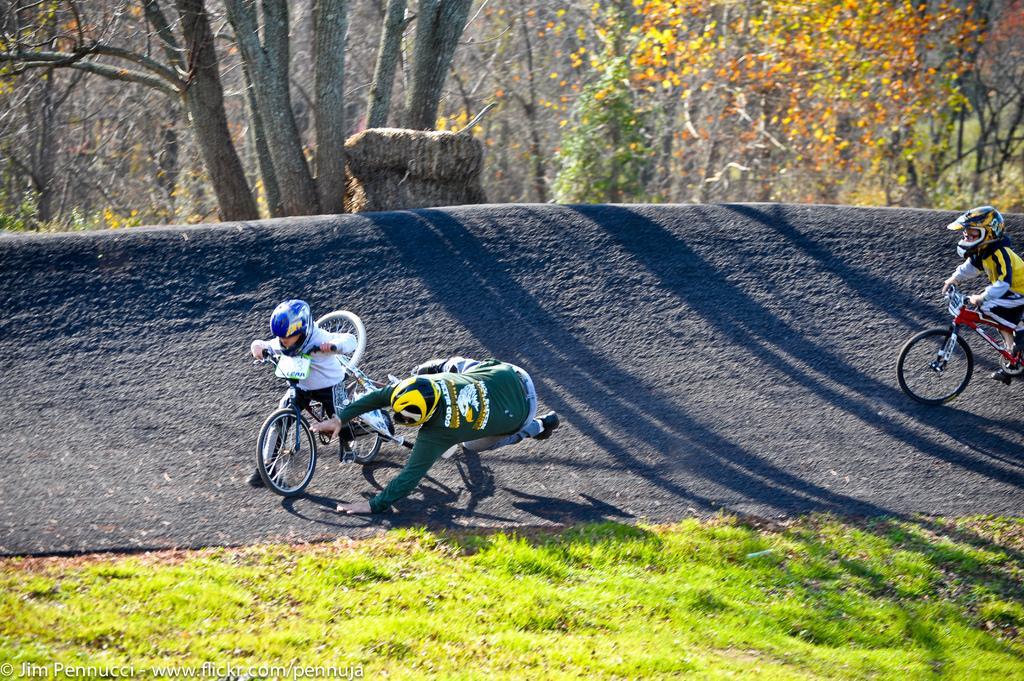In one or two sentences, can you explain what this image depicts? At the bottom of the image there is grass on the ground. Behind the grass there is a slope with few people are riding bicycles. At the top of the image there are many trees. 